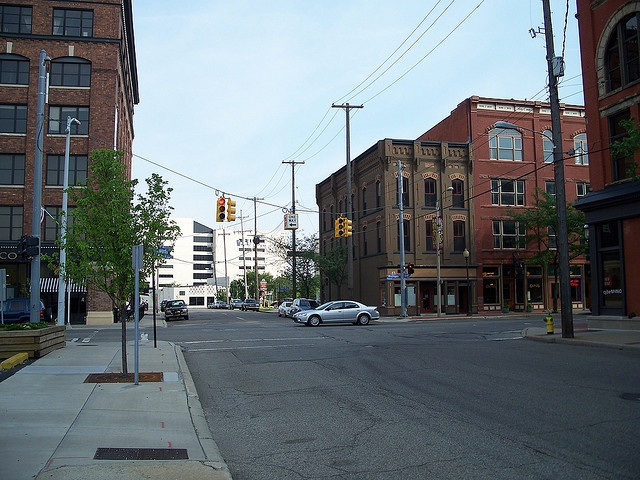Describe the objects in this image and their specific colors. I can see car in black, gray, and lightblue tones, car in black, navy, blue, and gray tones, car in black, gray, and darkgray tones, traffic light in black, olive, tan, and maroon tones, and car in black, blue, navy, and gray tones in this image. 